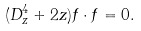<formula> <loc_0><loc_0><loc_500><loc_500>( D _ { z } ^ { 4 } + 2 z ) f \cdot f = 0 .</formula> 